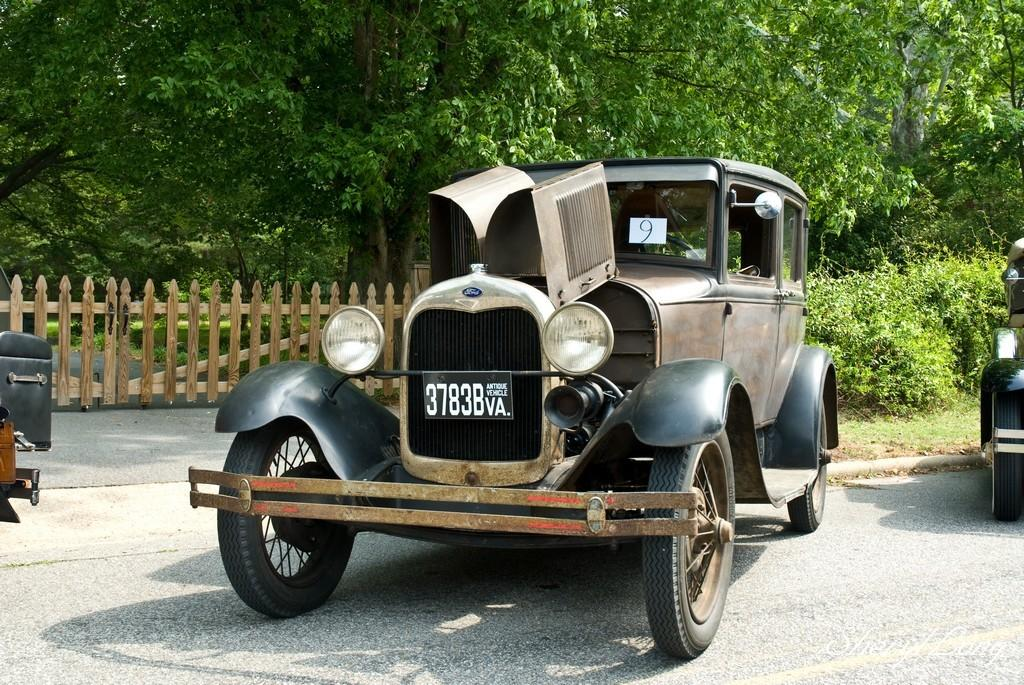What is on the road in the image? There is a vehicle on the road in the image. What type of barrier can be seen in the image? There is a wooden railing visible in the image. What color are the trees in the image? The trees in the image have green color. Who is the owner of the potato in the image? There is no potato present in the image, so it is not possible to determine the owner. 